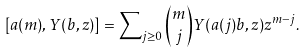Convert formula to latex. <formula><loc_0><loc_0><loc_500><loc_500>[ a ( m ) , Y ( b , z ) ] = \sum \nolimits _ { j \geq 0 } \binom { m } { j } Y ( a ( j ) b , z ) z ^ { m - j } .</formula> 